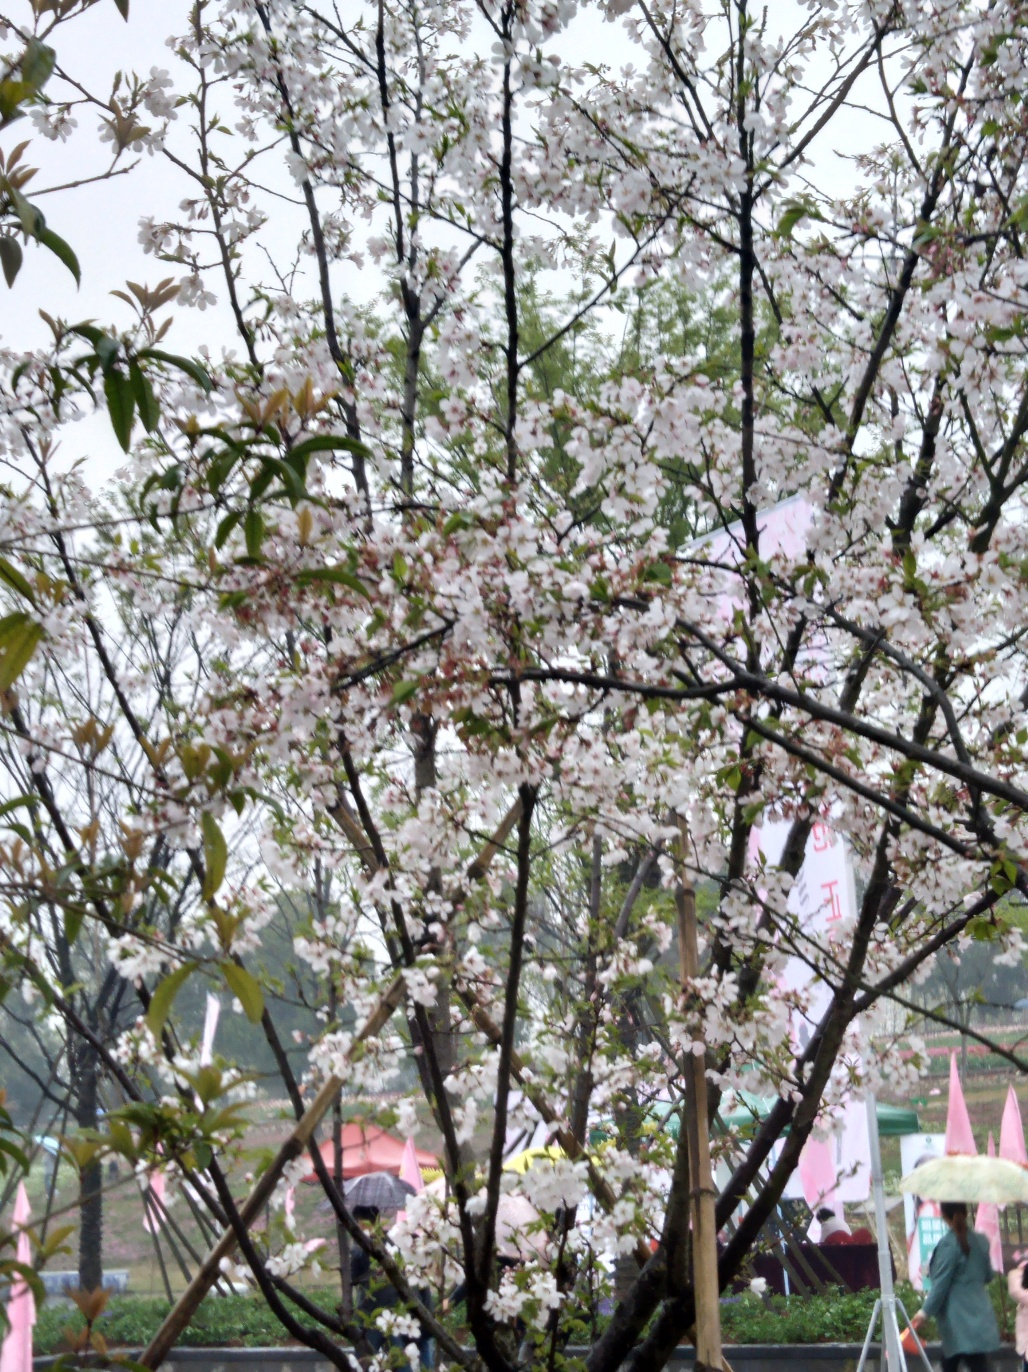What kind of tree is featured in this image, and what does it tell us about the season? The featured tree appears to be a cherry blossom, characterized by its soft, delicate flowers and the time of its bloom. This suggests that the image was taken in spring, which is the typical season for cherry blossoms to flourish, signaling a time of renewal and the beauty of nature's cycles. 